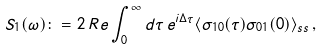<formula> <loc_0><loc_0><loc_500><loc_500>S _ { 1 } ( \omega ) \colon = 2 \, R e \int _ { 0 } ^ { \infty } d \tau \, e ^ { i \Delta \tau } \langle \sigma _ { 1 0 } ( \tau ) \sigma _ { 0 1 } ( 0 ) \rangle _ { s s } \, ,</formula> 